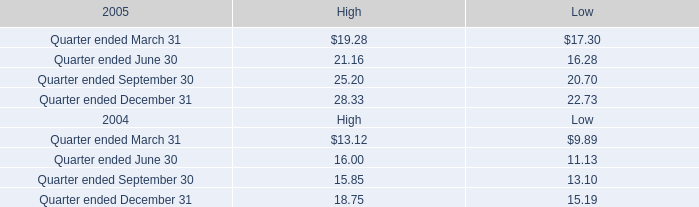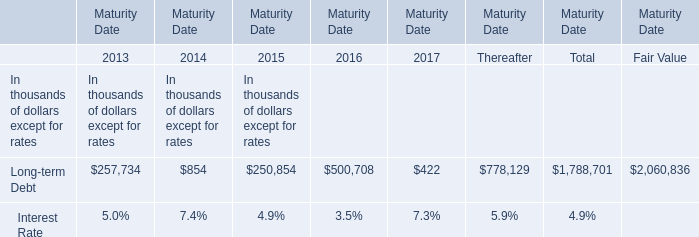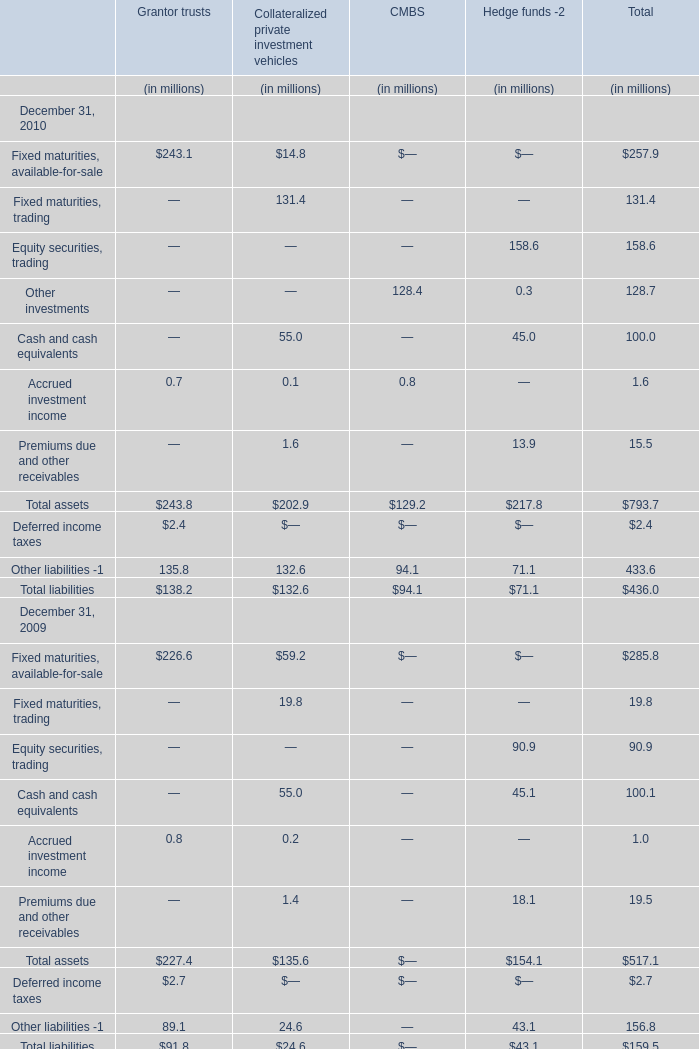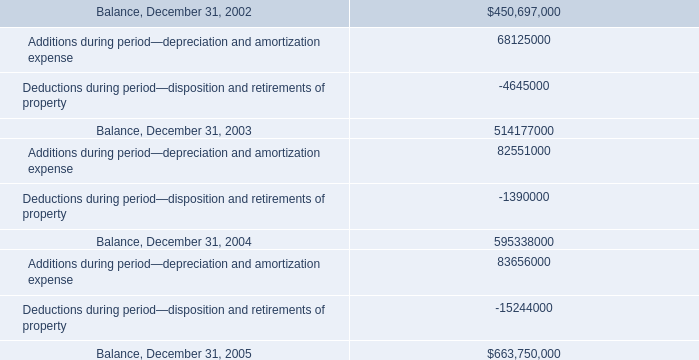What was the total amount of the assets in total in the years where Fixed maturities, trading in total greater than 100? (in million) 
Computations: ((((((257.9 + 131.4) + 158.6) + 128.7) + 100) + 1.6) + 15.5)
Answer: 793.7. 